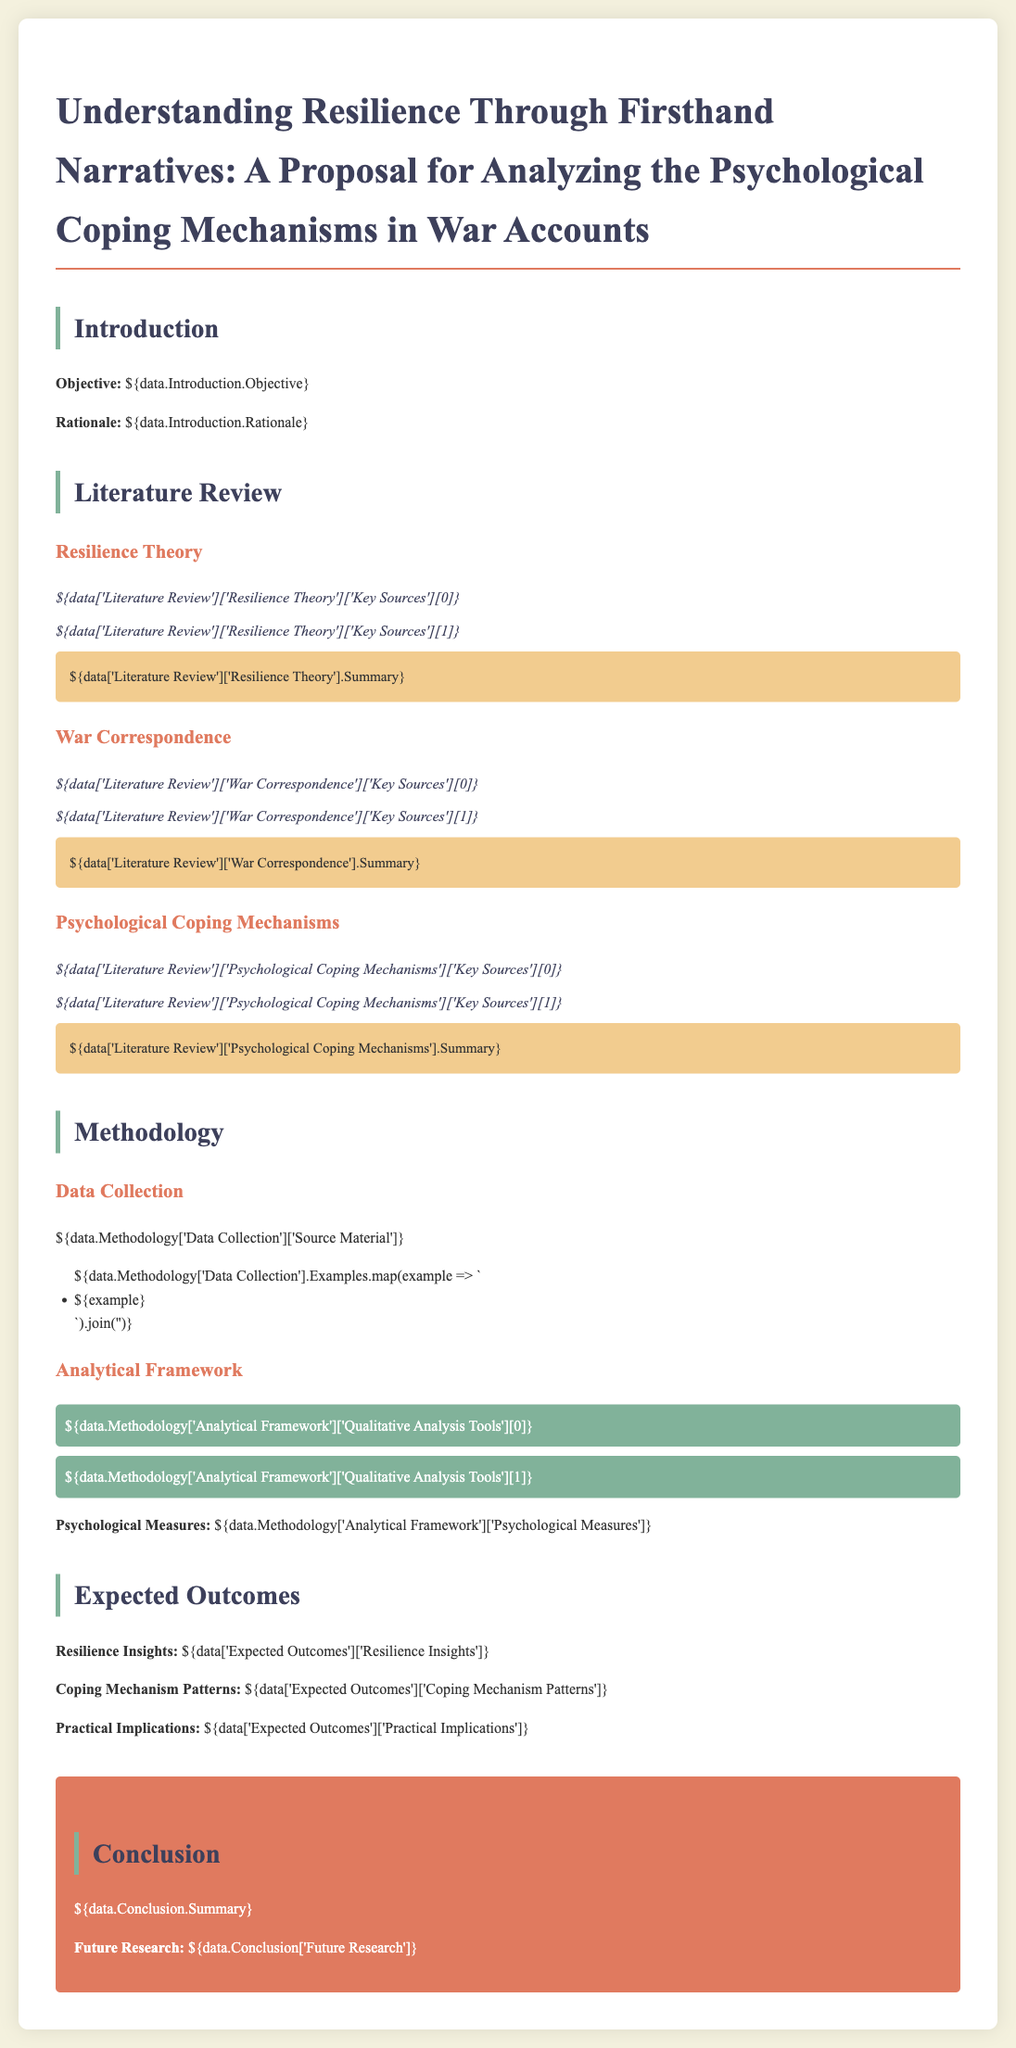what is the title of the proposal? The title of the proposal includes the theme of resilience and analyzing psychological coping mechanisms in war accounts.
Answer: Understanding Resilience Through Firsthand Narratives: A Proposal for Analyzing the Psychological Coping Mechanisms in War Accounts what does the objective focus on? The objective summarizes the main goal of the research, which is to explore resilience through narratives.
Answer: Understanding resilience through firsthand narratives who are the key sources related to resilience theory? The document lists specific authors or pieces of research that inform the resilience theory section.
Answer: 1. Key source 1, 2. Key source 2 what methodology is mentioned for data collection? This describes the approach taken to gather source material for the research proposal.
Answer: Qualitative analysis of firsthand narratives which section discusses coping mechanism patterns? This focuses on the expected outcomes of the research proposal regarding psychological coping mechanisms.
Answer: Expected Outcomes what is one expected practical implication of the research? This details a consequence or actionable insight derived from the research findings.
Answer: Practical application in psychological resilience strategies how many qualitative analysis tools are listed in the methodology? This indicates the number of tools identified for qualitative analysis within the proposed research.
Answer: 2 what future research direction is suggested? This indicates a possible area that will be explored further based on the research findings.
Answer: Exploring long-term resilience impacts 